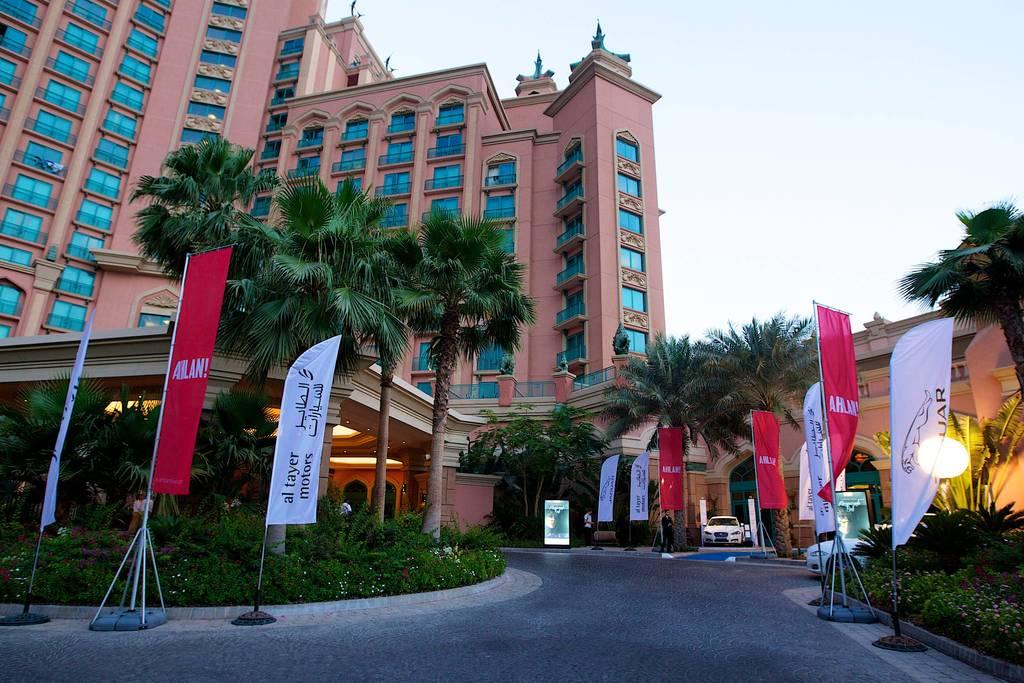What type of objects are used for advertising in the image? There are advertising flags in the image. What type of living organisms can be seen in the image? Plants, flowers, and trees are visible in the image. What type of transportation can be seen in the image? Vehicles are present in the image. Are there any human figures in the image? Yes, there are people in the image. What type of structure is visible in the image? There is a building in the image. What part of the natural environment is visible in the image? The sky is visible in the image. How many kittens are playing with a collar in the image? There are no kittens or collars present in the image. What type of bird is perched on the wren in the image? There is no wren present in the image. 